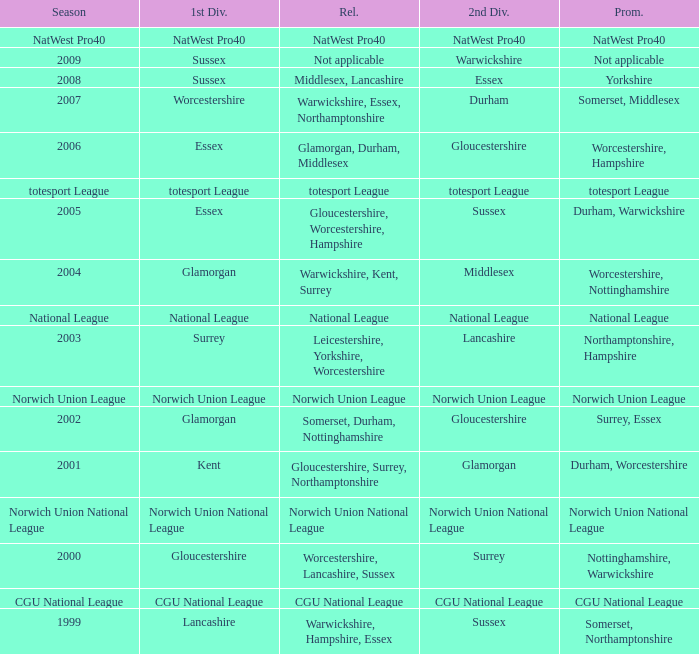What was relegated in the 2nd division of middlesex? Warwickshire, Kent, Surrey. 